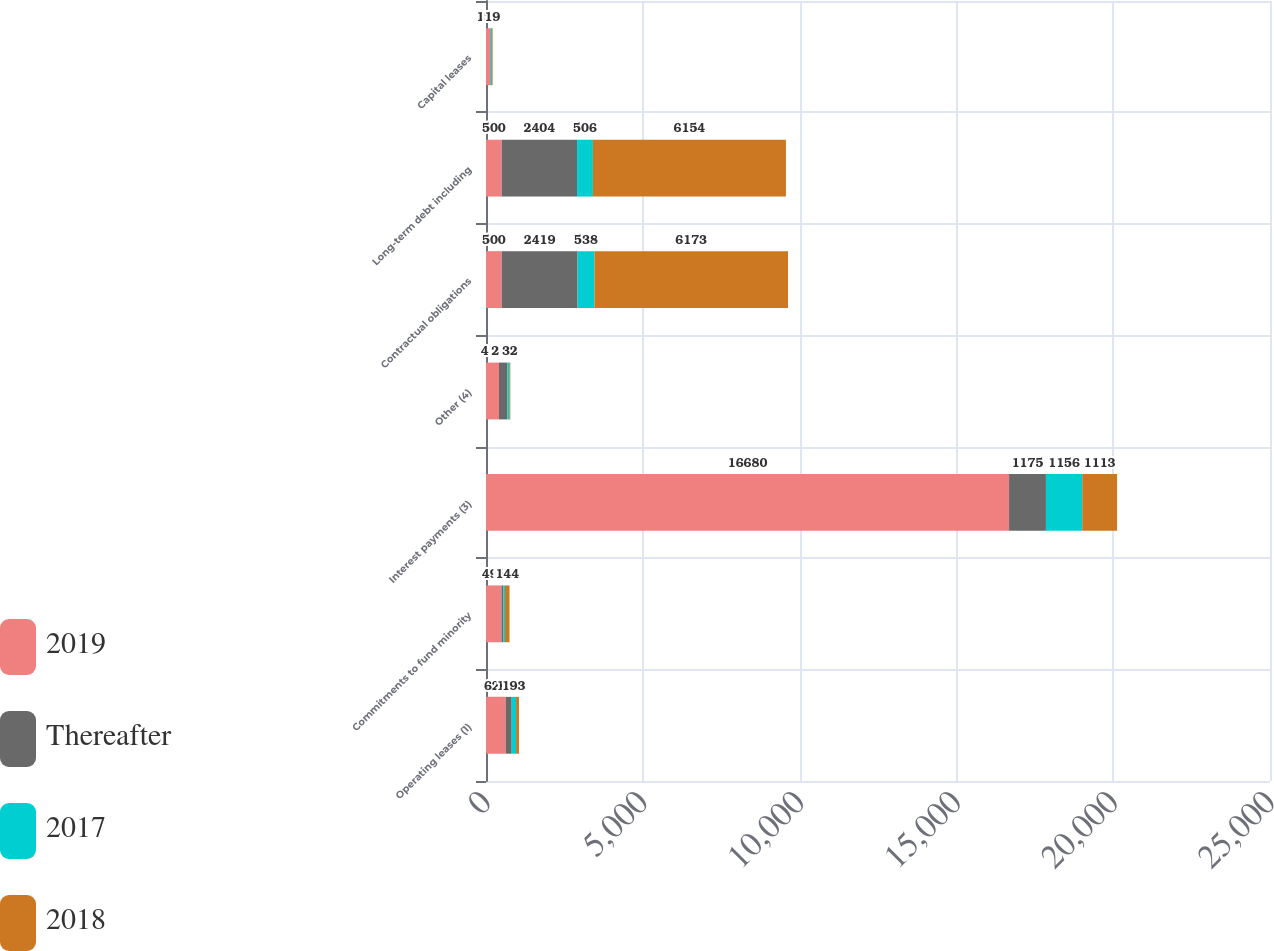Convert chart to OTSL. <chart><loc_0><loc_0><loc_500><loc_500><stacked_bar_chart><ecel><fcel>Operating leases (1)<fcel>Commitments to fund minority<fcel>Interest payments (3)<fcel>Other (4)<fcel>Contractual obligations<fcel>Long-term debt including<fcel>Capital leases<nl><fcel>2019<fcel>624<fcel>494<fcel>16680<fcel>415<fcel>500<fcel>500<fcel>145<nl><fcel>Thereafter<fcel>196<fcel>58<fcel>1175<fcel>265<fcel>2419<fcel>2404<fcel>15<nl><fcel>2017<fcel>138<fcel>54<fcel>1156<fcel>63<fcel>538<fcel>506<fcel>32<nl><fcel>2018<fcel>93<fcel>144<fcel>1113<fcel>32<fcel>6173<fcel>6154<fcel>19<nl></chart> 